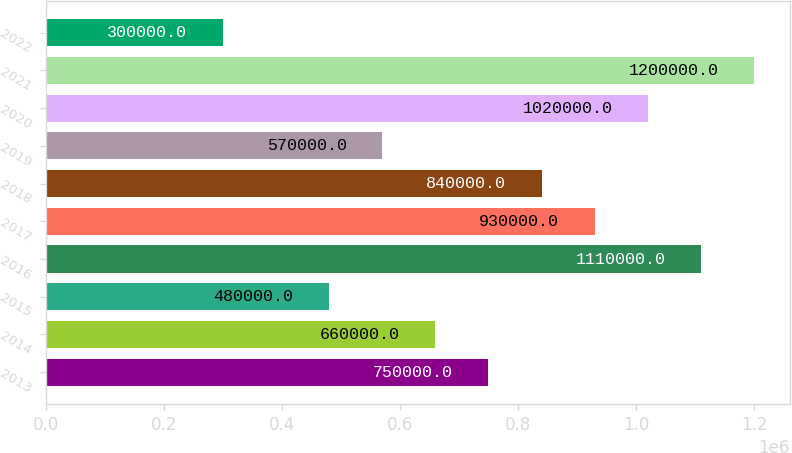Convert chart to OTSL. <chart><loc_0><loc_0><loc_500><loc_500><bar_chart><fcel>2013<fcel>2014<fcel>2015<fcel>2016<fcel>2017<fcel>2018<fcel>2019<fcel>2020<fcel>2021<fcel>2022<nl><fcel>750000<fcel>660000<fcel>480000<fcel>1.11e+06<fcel>930000<fcel>840000<fcel>570000<fcel>1.02e+06<fcel>1.2e+06<fcel>300000<nl></chart> 